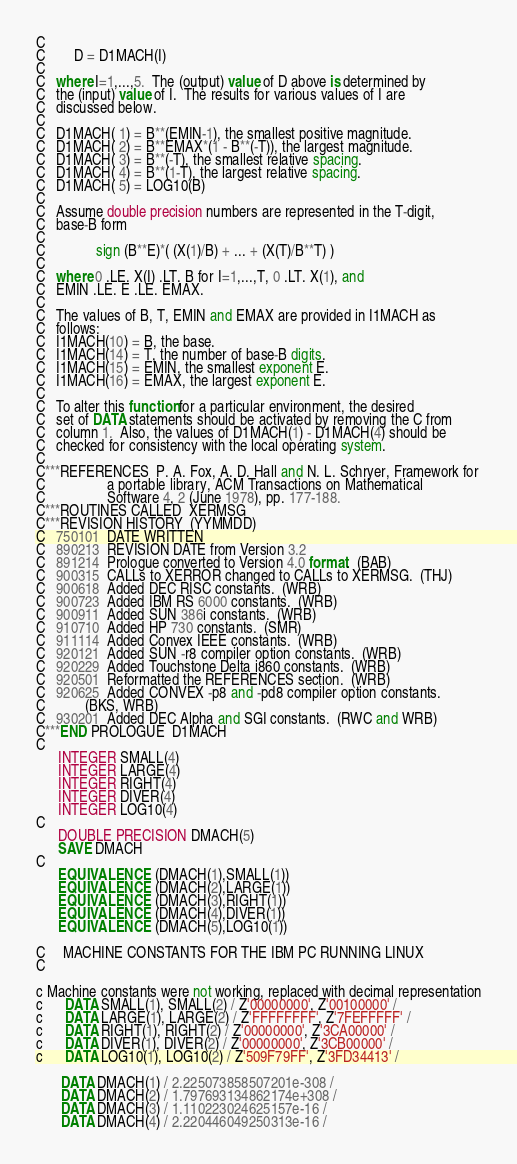Convert code to text. <code><loc_0><loc_0><loc_500><loc_500><_FORTRAN_>C
C        D = D1MACH(I)
C
C   where I=1,...,5.  The (output) value of D above is determined by
C   the (input) value of I.  The results for various values of I are
C   discussed below.
C
C   D1MACH( 1) = B**(EMIN-1), the smallest positive magnitude.
C   D1MACH( 2) = B**EMAX*(1 - B**(-T)), the largest magnitude.
C   D1MACH( 3) = B**(-T), the smallest relative spacing.
C   D1MACH( 4) = B**(1-T), the largest relative spacing.
C   D1MACH( 5) = LOG10(B)
C
C   Assume double precision numbers are represented in the T-digit,
C   base-B form
C
C              sign (B**E)*( (X(1)/B) + ... + (X(T)/B**T) )
C
C   where 0 .LE. X(I) .LT. B for I=1,...,T, 0 .LT. X(1), and
C   EMIN .LE. E .LE. EMAX.
C
C   The values of B, T, EMIN and EMAX are provided in I1MACH as
C   follows:
C   I1MACH(10) = B, the base.
C   I1MACH(14) = T, the number of base-B digits.
C   I1MACH(15) = EMIN, the smallest exponent E.
C   I1MACH(16) = EMAX, the largest exponent E.
C
C   To alter this function for a particular environment, the desired
C   set of DATA statements should be activated by removing the C from
C   column 1.  Also, the values of D1MACH(1) - D1MACH(4) should be
C   checked for consistency with the local operating system.
C
C***REFERENCES  P. A. Fox, A. D. Hall and N. L. Schryer, Framework for
C                 a portable library, ACM Transactions on Mathematical
C                 Software 4, 2 (June 1978), pp. 177-188.
C***ROUTINES CALLED  XERMSG
C***REVISION HISTORY  (YYMMDD)
C   750101  DATE WRITTEN
C   890213  REVISION DATE from Version 3.2
C   891214  Prologue converted to Version 4.0 format.  (BAB)
C   900315  CALLs to XERROR changed to CALLs to XERMSG.  (THJ)
C   900618  Added DEC RISC constants.  (WRB)
C   900723  Added IBM RS 6000 constants.  (WRB)
C   900911  Added SUN 386i constants.  (WRB)
C   910710  Added HP 730 constants.  (SMR)
C   911114  Added Convex IEEE constants.  (WRB)
C   920121  Added SUN -r8 compiler option constants.  (WRB)
C   920229  Added Touchstone Delta i860 constants.  (WRB)
C   920501  Reformatted the REFERENCES section.  (WRB)
C   920625  Added CONVEX -p8 and -pd8 compiler option constants.
C           (BKS, WRB)
C   930201  Added DEC Alpha and SGI constants.  (RWC and WRB)
C***END PROLOGUE  D1MACH
C
      INTEGER SMALL(4)
      INTEGER LARGE(4)
      INTEGER RIGHT(4)
      INTEGER DIVER(4)
      INTEGER LOG10(4)
C
      DOUBLE PRECISION DMACH(5)
      SAVE DMACH
C
      EQUIVALENCE (DMACH(1),SMALL(1))
      EQUIVALENCE (DMACH(2),LARGE(1))
      EQUIVALENCE (DMACH(3),RIGHT(1))
      EQUIVALENCE (DMACH(4),DIVER(1))
      EQUIVALENCE (DMACH(5),LOG10(1))

C     MACHINE CONSTANTS FOR THE IBM PC RUNNING LINUX
C

c Machine constants were not working, replaced with decimal representation
c      DATA SMALL(1), SMALL(2) / Z'00000000', Z'00100000' /
c      DATA LARGE(1), LARGE(2) / Z'FFFFFFFF', Z'7FEFFFFF' /
c      DATA RIGHT(1), RIGHT(2) / Z'00000000', Z'3CA00000' /
c      DATA DIVER(1), DIVER(2) / Z'00000000', Z'3CB00000' /
c      DATA LOG10(1), LOG10(2) / Z'509F79FF', Z'3FD34413' /

       DATA DMACH(1) / 2.225073858507201e-308 / 
       DATA DMACH(2) / 1.797693134862174e+308 / 
       DATA DMACH(3) / 1.110223024625157e-16 / 
       DATA DMACH(4) / 2.220446049250313e-16 / </code> 